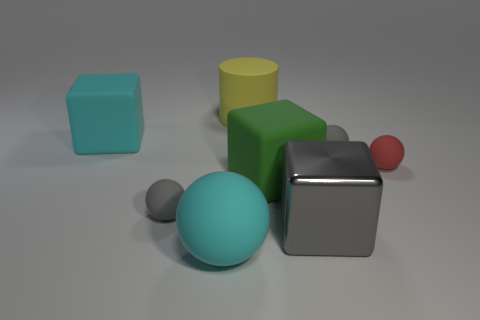There is a matte thing that is the same color as the large ball; what size is it?
Your answer should be compact. Large. There is a large cyan thing that is behind the green rubber thing; what is it made of?
Offer a terse response. Rubber. What is the large yellow cylinder made of?
Your response must be concise. Rubber. Is the material of the gray thing right of the big gray shiny object the same as the red ball?
Your answer should be very brief. Yes. Is the number of gray objects that are on the left side of the green object less than the number of matte things?
Give a very brief answer. Yes. What color is the cylinder that is the same size as the cyan matte cube?
Make the answer very short. Yellow. How many other large yellow objects are the same shape as the big yellow thing?
Provide a short and direct response. 0. What color is the tiny thing left of the large gray thing?
Offer a very short reply. Gray. How many metallic things are small gray objects or balls?
Make the answer very short. 0. There is a large thing that is the same color as the large rubber sphere; what is its shape?
Your answer should be compact. Cube. 